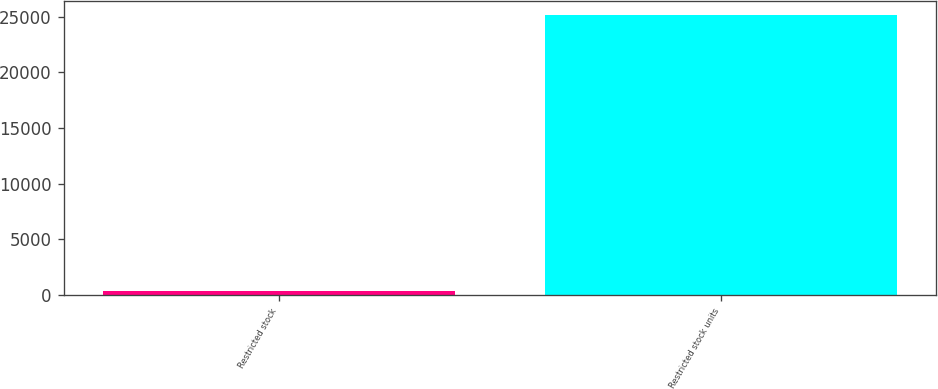Convert chart. <chart><loc_0><loc_0><loc_500><loc_500><bar_chart><fcel>Restricted stock<fcel>Restricted stock units<nl><fcel>349<fcel>25183<nl></chart> 